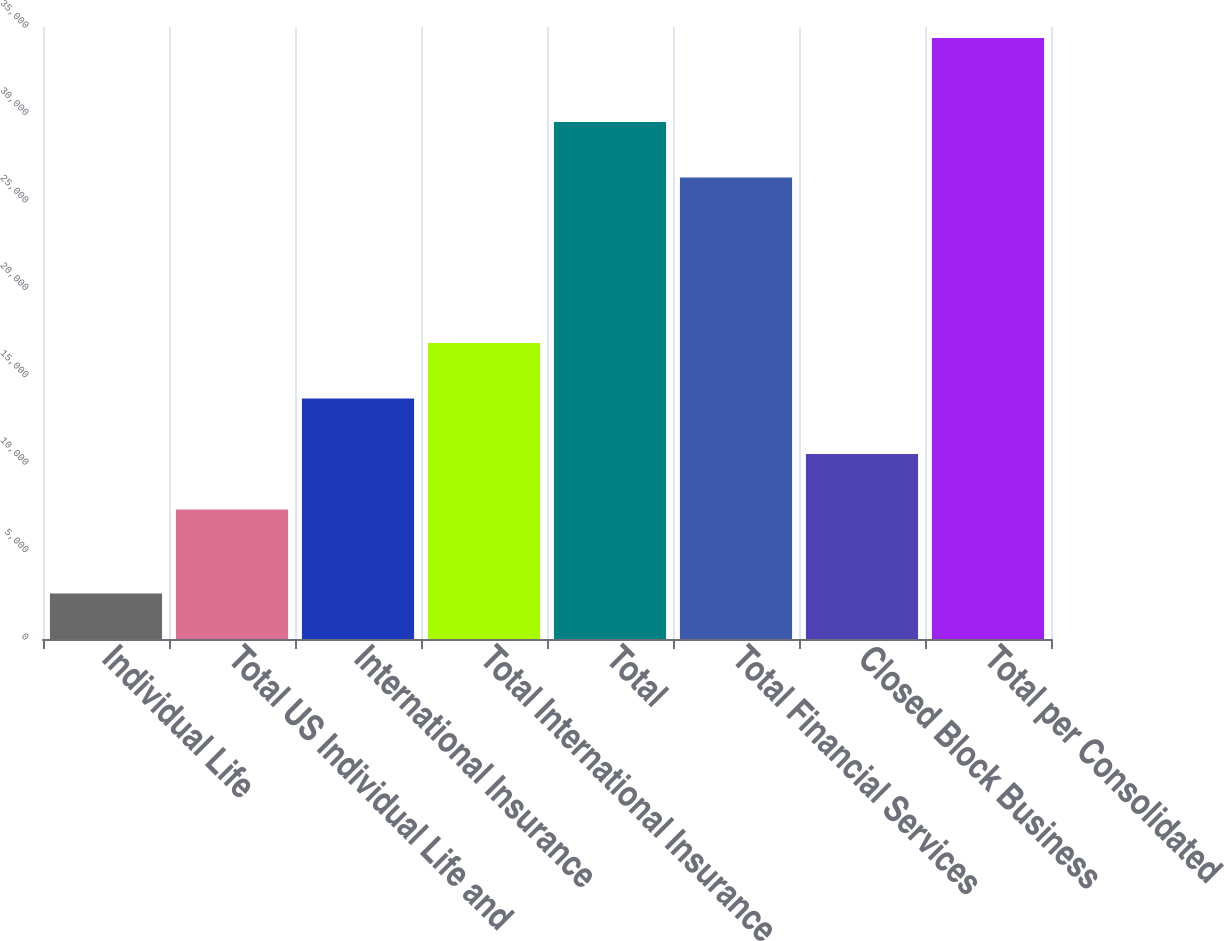Convert chart. <chart><loc_0><loc_0><loc_500><loc_500><bar_chart><fcel>Individual Life<fcel>Total US Individual Life and<fcel>International Insurance<fcel>Total International Insurance<fcel>Total<fcel>Total Financial Services<fcel>Closed Block Business<fcel>Total per Consolidated<nl><fcel>2602<fcel>7401<fcel>13756<fcel>16933.5<fcel>29573.5<fcel>26396<fcel>10578.5<fcel>34377<nl></chart> 